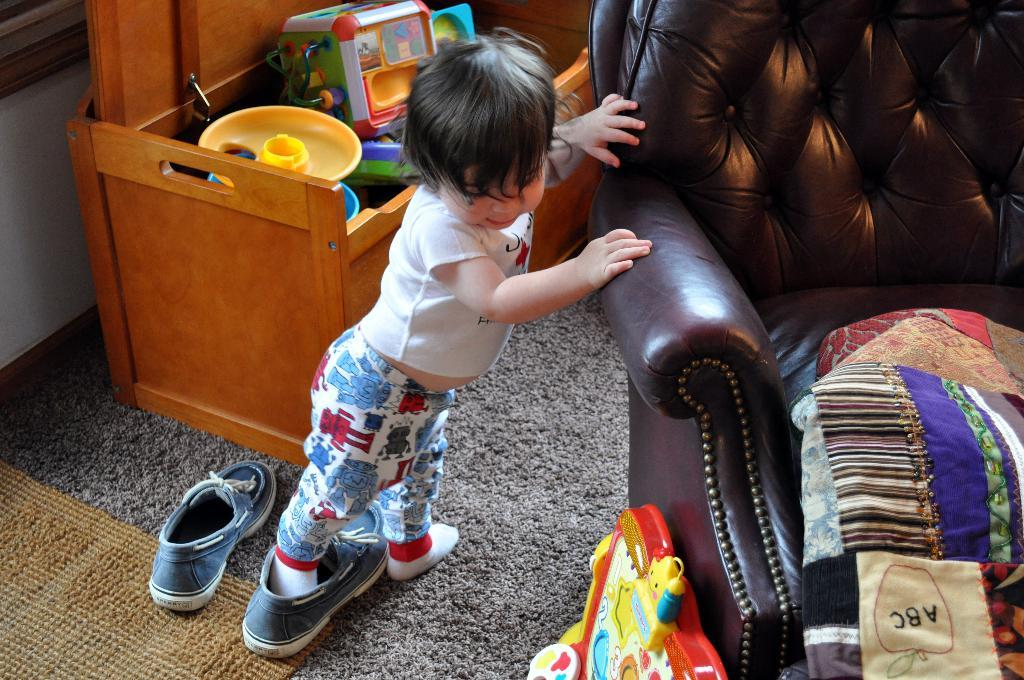What is the main subject of the image? The main subject of the image is a small kid. Where is the kid located in relation to other objects in the image? The kid is standing beside a sofa chair. What can be seen behind the kid in the image? There is a box full of toys behind the kid. What type of chalk is the kid using to draw on the alarm clock in the image? There is no chalk or alarm clock present in the image. Is the kid sleeping in the image? The image does not show the kid sleeping; they are standing beside a sofa chair. 